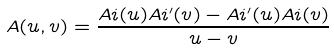<formula> <loc_0><loc_0><loc_500><loc_500>A ( u , v ) = \frac { A i ( u ) A i ^ { \prime } ( v ) - A i ^ { \prime } ( u ) A i ( v ) } { u - v }</formula> 